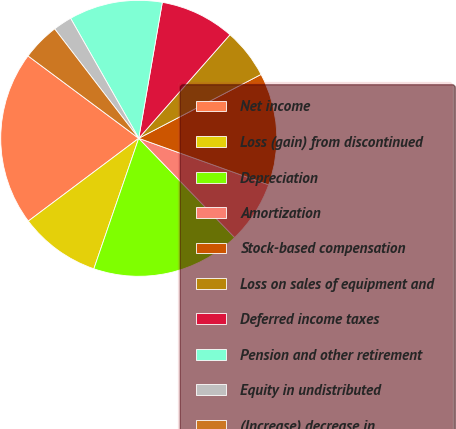<chart> <loc_0><loc_0><loc_500><loc_500><pie_chart><fcel>Net income<fcel>Loss (gain) from discontinued<fcel>Depreciation<fcel>Amortization<fcel>Stock-based compensation<fcel>Loss on sales of equipment and<fcel>Deferred income taxes<fcel>Pension and other retirement<fcel>Equity in undistributed<fcel>(Increase) decrease in<nl><fcel>20.42%<fcel>9.49%<fcel>17.5%<fcel>7.3%<fcel>13.13%<fcel>5.85%<fcel>8.76%<fcel>10.95%<fcel>2.21%<fcel>4.39%<nl></chart> 